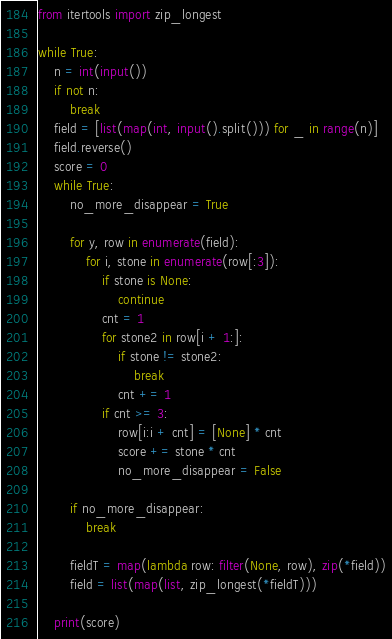<code> <loc_0><loc_0><loc_500><loc_500><_Python_>from itertools import zip_longest

while True:
    n = int(input())
    if not n:
        break
    field = [list(map(int, input().split())) for _ in range(n)]
    field.reverse()
    score = 0
    while True:
        no_more_disappear = True

        for y, row in enumerate(field):
            for i, stone in enumerate(row[:3]):
                if stone is None:
                    continue
                cnt = 1
                for stone2 in row[i + 1:]:
                    if stone != stone2:
                        break
                    cnt += 1
                if cnt >= 3:
                    row[i:i + cnt] = [None] * cnt
                    score += stone * cnt
                    no_more_disappear = False

        if no_more_disappear:
            break

        fieldT = map(lambda row: filter(None, row), zip(*field))
        field = list(map(list, zip_longest(*fieldT)))

    print(score)</code> 